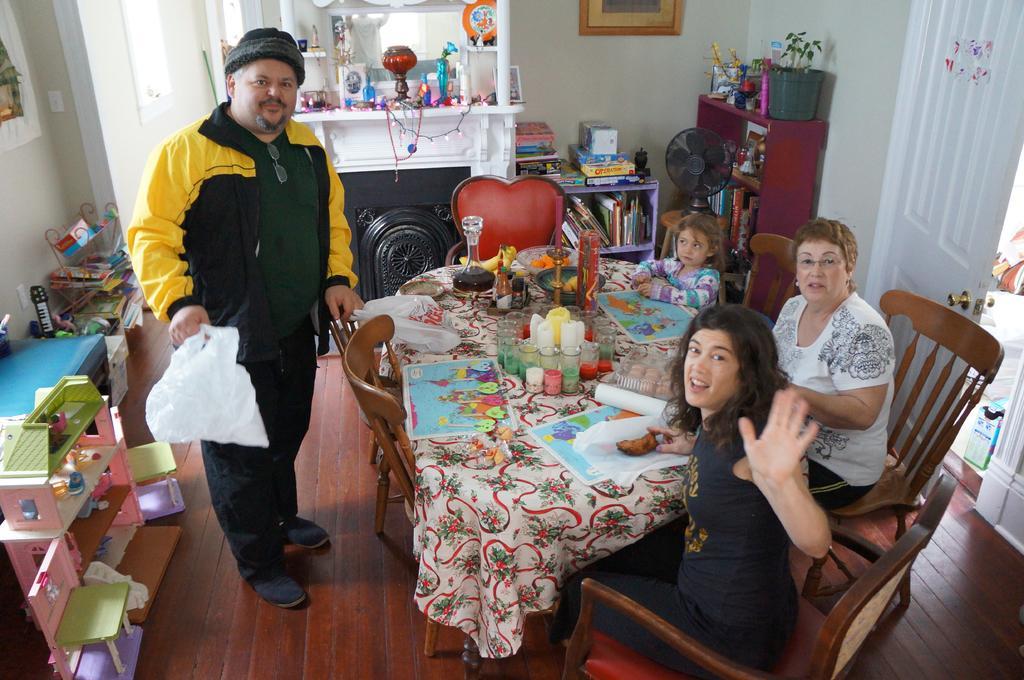Describe this image in one or two sentences. In this picture there is a table on which some accessories were placed two women and a girl were sitting around the table in their chairs and man is standing in front of a table. Beside him there is a small cupboard. In the background there is a shelf. Beside the shell there are some books placed. We can observe a wall here. 